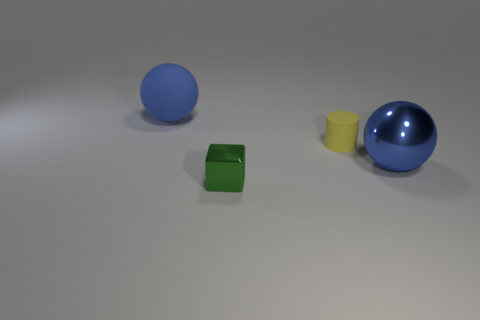Add 2 yellow things. How many objects exist? 6 Subtract all cylinders. How many objects are left? 3 Subtract 0 gray cubes. How many objects are left? 4 Subtract all large blue rubber objects. Subtract all small yellow rubber cylinders. How many objects are left? 2 Add 3 blue balls. How many blue balls are left? 5 Add 2 large blue rubber balls. How many large blue rubber balls exist? 3 